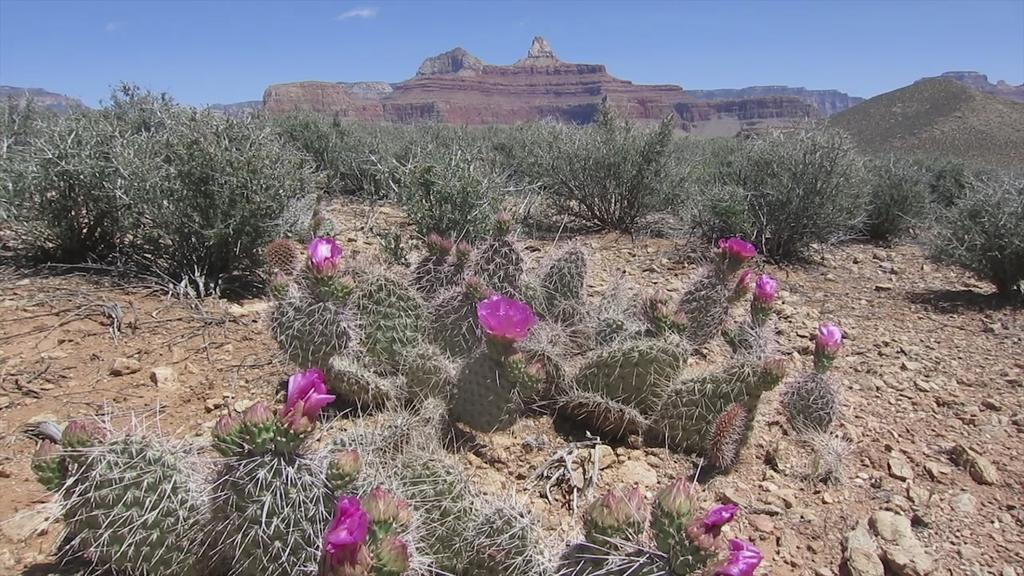What type of living organisms can be seen in the image? Plants and flowers are visible in the image. What type of landscape feature is present in the image? There are hills in the image. What is visible in the background of the image? The sky is visible in the background of the image. What type of insurance policy is being discussed in the image? There is no discussion of insurance policies in the image; it features plants, flowers, hills, and the sky. 